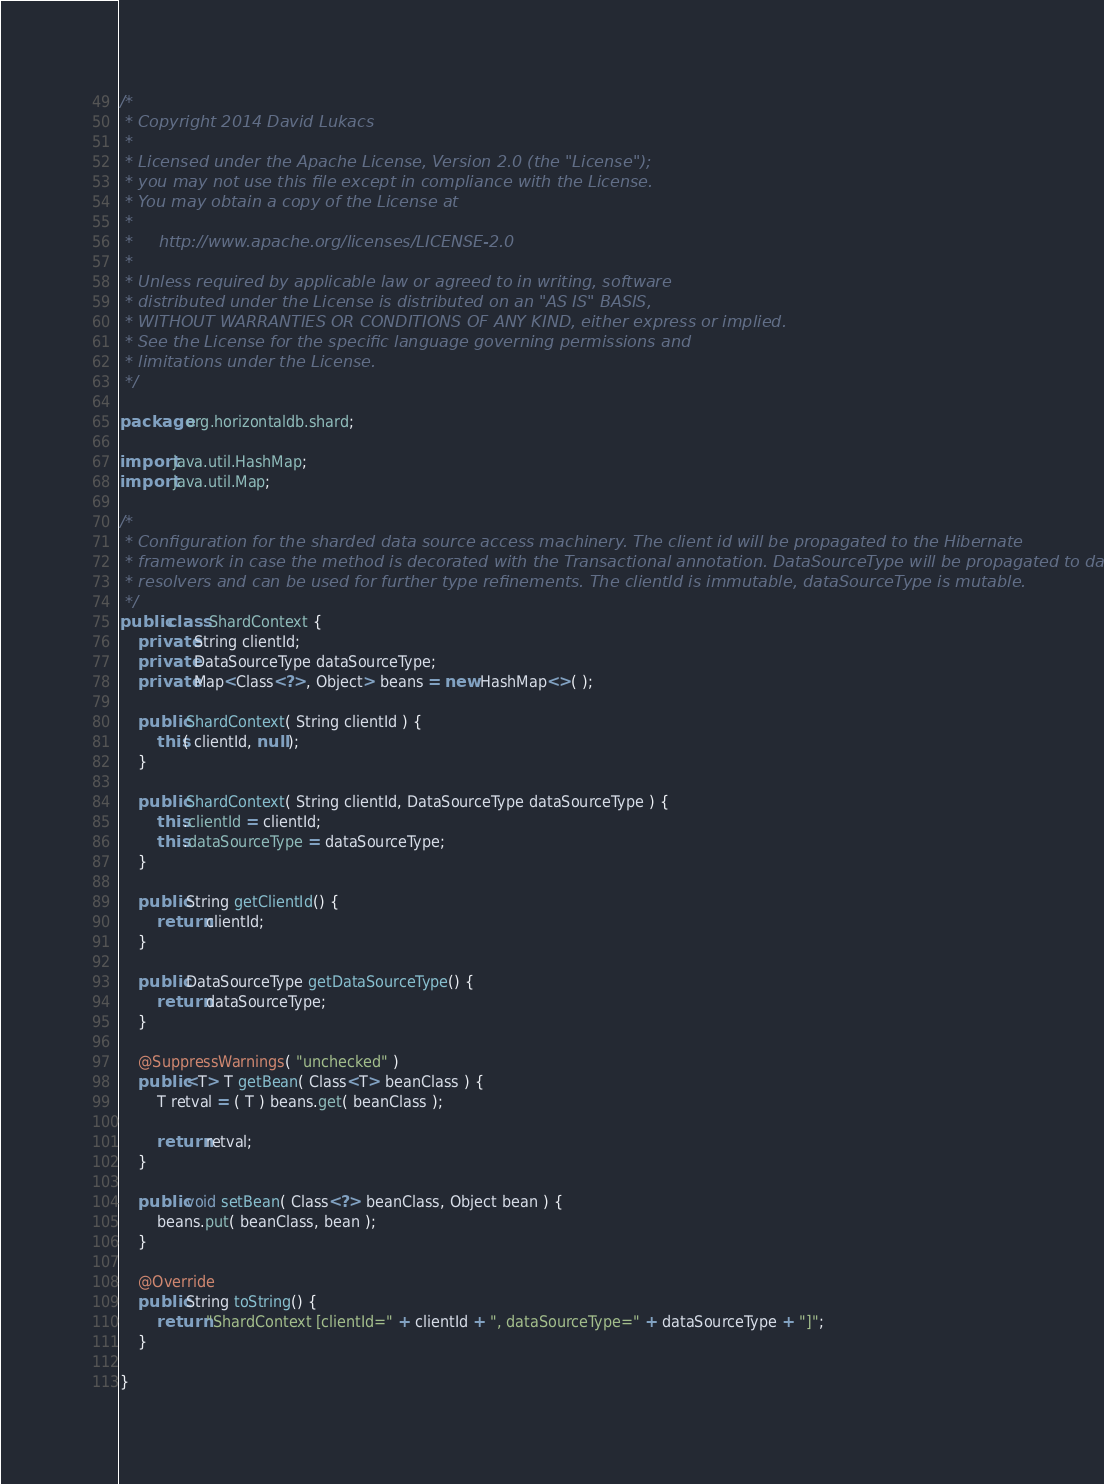<code> <loc_0><loc_0><loc_500><loc_500><_Java_>/*
 * Copyright 2014 David Lukacs
 *
 * Licensed under the Apache License, Version 2.0 (the "License");
 * you may not use this file except in compliance with the License.
 * You may obtain a copy of the License at
 *
 *     http://www.apache.org/licenses/LICENSE-2.0
 *
 * Unless required by applicable law or agreed to in writing, software
 * distributed under the License is distributed on an "AS IS" BASIS,
 * WITHOUT WARRANTIES OR CONDITIONS OF ANY KIND, either express or implied.
 * See the License for the specific language governing permissions and
 * limitations under the License.
 */

package org.horizontaldb.shard;

import java.util.HashMap;
import java.util.Map;

/*
 * Configuration for the sharded data source access machinery. The client id will be propagated to the Hibernate
 * framework in case the method is decorated with the Transactional annotation. DataSourceType will be propagated to dao
 * resolvers and can be used for further type refinements. The clientId is immutable, dataSourceType is mutable.
 */
public class ShardContext {
    private String clientId;
    private DataSourceType dataSourceType;
    private Map<Class<?>, Object> beans = new HashMap<>( );

    public ShardContext( String clientId ) {
        this( clientId, null );
    }

    public ShardContext( String clientId, DataSourceType dataSourceType ) {
        this.clientId = clientId;
        this.dataSourceType = dataSourceType;
    }

    public String getClientId() {
        return clientId;
    }

    public DataSourceType getDataSourceType() {
        return dataSourceType;
    }

    @SuppressWarnings( "unchecked" )
    public <T> T getBean( Class<T> beanClass ) {
        T retval = ( T ) beans.get( beanClass );

        return retval;
    }

    public void setBean( Class<?> beanClass, Object bean ) {
        beans.put( beanClass, bean );
    }

    @Override
    public String toString() {
        return "ShardContext [clientId=" + clientId + ", dataSourceType=" + dataSourceType + "]";
    }

}
</code> 